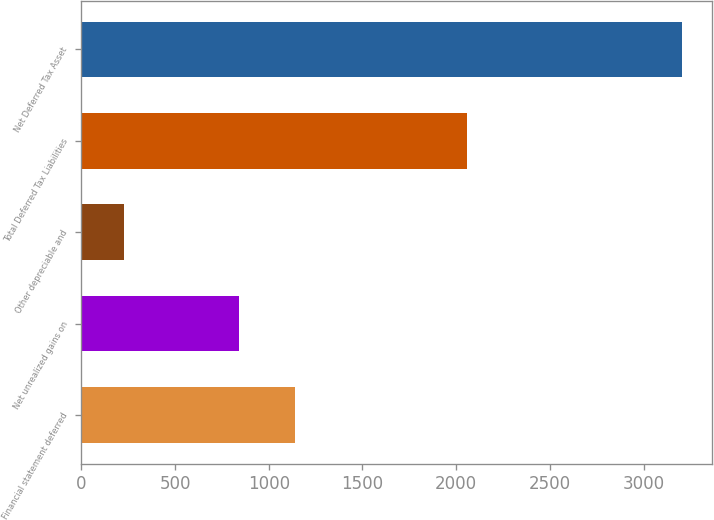<chart> <loc_0><loc_0><loc_500><loc_500><bar_chart><fcel>Financial statement deferred<fcel>Net unrealized gains on<fcel>Other depreciable and<fcel>Total Deferred Tax Liabilities<fcel>Net Deferred Tax Asset<nl><fcel>1139.7<fcel>842<fcel>229<fcel>2056<fcel>3206<nl></chart> 